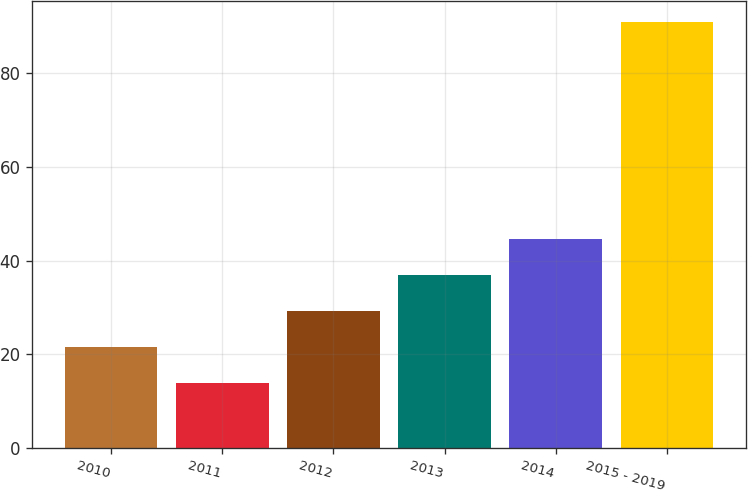<chart> <loc_0><loc_0><loc_500><loc_500><bar_chart><fcel>2010<fcel>2011<fcel>2012<fcel>2013<fcel>2014<fcel>2015 - 2019<nl><fcel>21.6<fcel>13.9<fcel>29.3<fcel>37<fcel>44.7<fcel>90.9<nl></chart> 